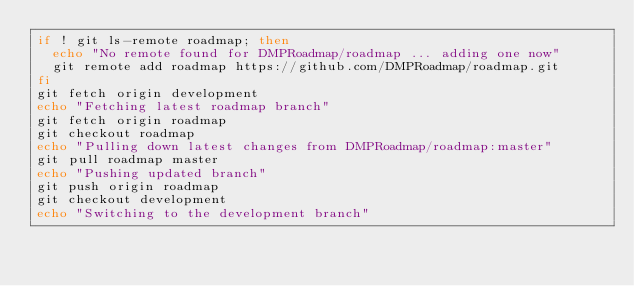Convert code to text. <code><loc_0><loc_0><loc_500><loc_500><_Bash_>if ! git ls-remote roadmap; then
  echo "No remote found for DMPRoadmap/roadmap ... adding one now"
  git remote add roadmap https://github.com/DMPRoadmap/roadmap.git
fi
git fetch origin development
echo "Fetching latest roadmap branch"
git fetch origin roadmap
git checkout roadmap
echo "Pulling down latest changes from DMPRoadmap/roadmap:master"
git pull roadmap master
echo "Pushing updated branch"
git push origin roadmap
git checkout development
echo "Switching to the development branch"
</code> 